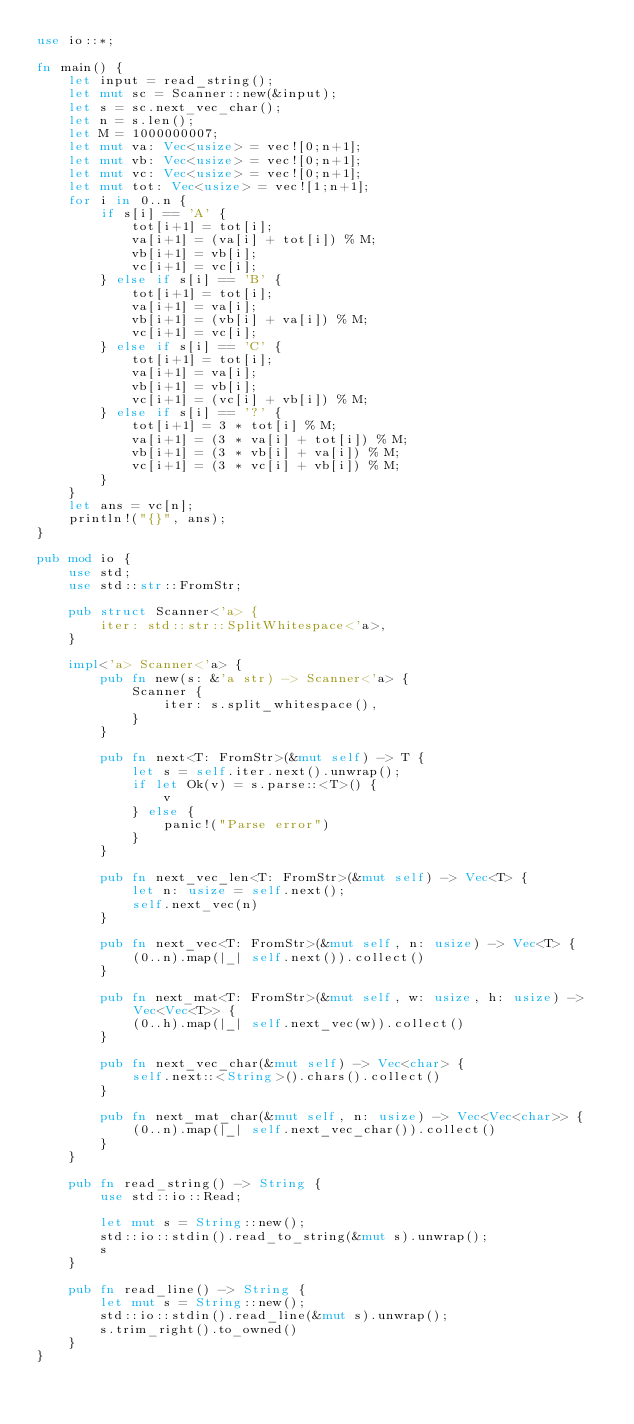Convert code to text. <code><loc_0><loc_0><loc_500><loc_500><_Rust_>use io::*;

fn main() {
    let input = read_string();
    let mut sc = Scanner::new(&input);
    let s = sc.next_vec_char();
    let n = s.len();
    let M = 1000000007;
    let mut va: Vec<usize> = vec![0;n+1];
    let mut vb: Vec<usize> = vec![0;n+1];
    let mut vc: Vec<usize> = vec![0;n+1];
    let mut tot: Vec<usize> = vec![1;n+1];
    for i in 0..n {
        if s[i] == 'A' {
            tot[i+1] = tot[i];
            va[i+1] = (va[i] + tot[i]) % M;
            vb[i+1] = vb[i];
            vc[i+1] = vc[i];
        } else if s[i] == 'B' {
            tot[i+1] = tot[i];
            va[i+1] = va[i];
            vb[i+1] = (vb[i] + va[i]) % M;
            vc[i+1] = vc[i];
        } else if s[i] == 'C' {
            tot[i+1] = tot[i];
            va[i+1] = va[i];
            vb[i+1] = vb[i];
            vc[i+1] = (vc[i] + vb[i]) % M;
        } else if s[i] == '?' {
            tot[i+1] = 3 * tot[i] % M;
            va[i+1] = (3 * va[i] + tot[i]) % M;
            vb[i+1] = (3 * vb[i] + va[i]) % M;
            vc[i+1] = (3 * vc[i] + vb[i]) % M;
        }
    }
    let ans = vc[n];
    println!("{}", ans);
}

pub mod io {
    use std;
    use std::str::FromStr;

    pub struct Scanner<'a> {
        iter: std::str::SplitWhitespace<'a>,
    }

    impl<'a> Scanner<'a> {
        pub fn new(s: &'a str) -> Scanner<'a> {
            Scanner {
                iter: s.split_whitespace(),
            }
        }

        pub fn next<T: FromStr>(&mut self) -> T {
            let s = self.iter.next().unwrap();
            if let Ok(v) = s.parse::<T>() {
                v
            } else {
                panic!("Parse error")
            }
        }

        pub fn next_vec_len<T: FromStr>(&mut self) -> Vec<T> {
            let n: usize = self.next();
            self.next_vec(n)
        }

        pub fn next_vec<T: FromStr>(&mut self, n: usize) -> Vec<T> {
            (0..n).map(|_| self.next()).collect()
        }

        pub fn next_mat<T: FromStr>(&mut self, w: usize, h: usize) -> Vec<Vec<T>> {
            (0..h).map(|_| self.next_vec(w)).collect()
        }

        pub fn next_vec_char(&mut self) -> Vec<char> {
            self.next::<String>().chars().collect()
        }

        pub fn next_mat_char(&mut self, n: usize) -> Vec<Vec<char>> {
            (0..n).map(|_| self.next_vec_char()).collect()
        }
    }

    pub fn read_string() -> String {
        use std::io::Read;

        let mut s = String::new();
        std::io::stdin().read_to_string(&mut s).unwrap();
        s
    }

    pub fn read_line() -> String {
        let mut s = String::new();
        std::io::stdin().read_line(&mut s).unwrap();
        s.trim_right().to_owned()
    }
}
</code> 